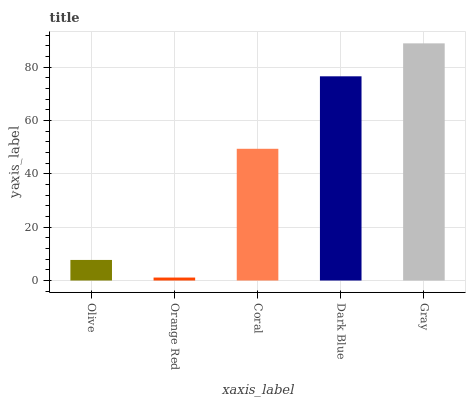Is Coral the minimum?
Answer yes or no. No. Is Coral the maximum?
Answer yes or no. No. Is Coral greater than Orange Red?
Answer yes or no. Yes. Is Orange Red less than Coral?
Answer yes or no. Yes. Is Orange Red greater than Coral?
Answer yes or no. No. Is Coral less than Orange Red?
Answer yes or no. No. Is Coral the high median?
Answer yes or no. Yes. Is Coral the low median?
Answer yes or no. Yes. Is Dark Blue the high median?
Answer yes or no. No. Is Gray the low median?
Answer yes or no. No. 